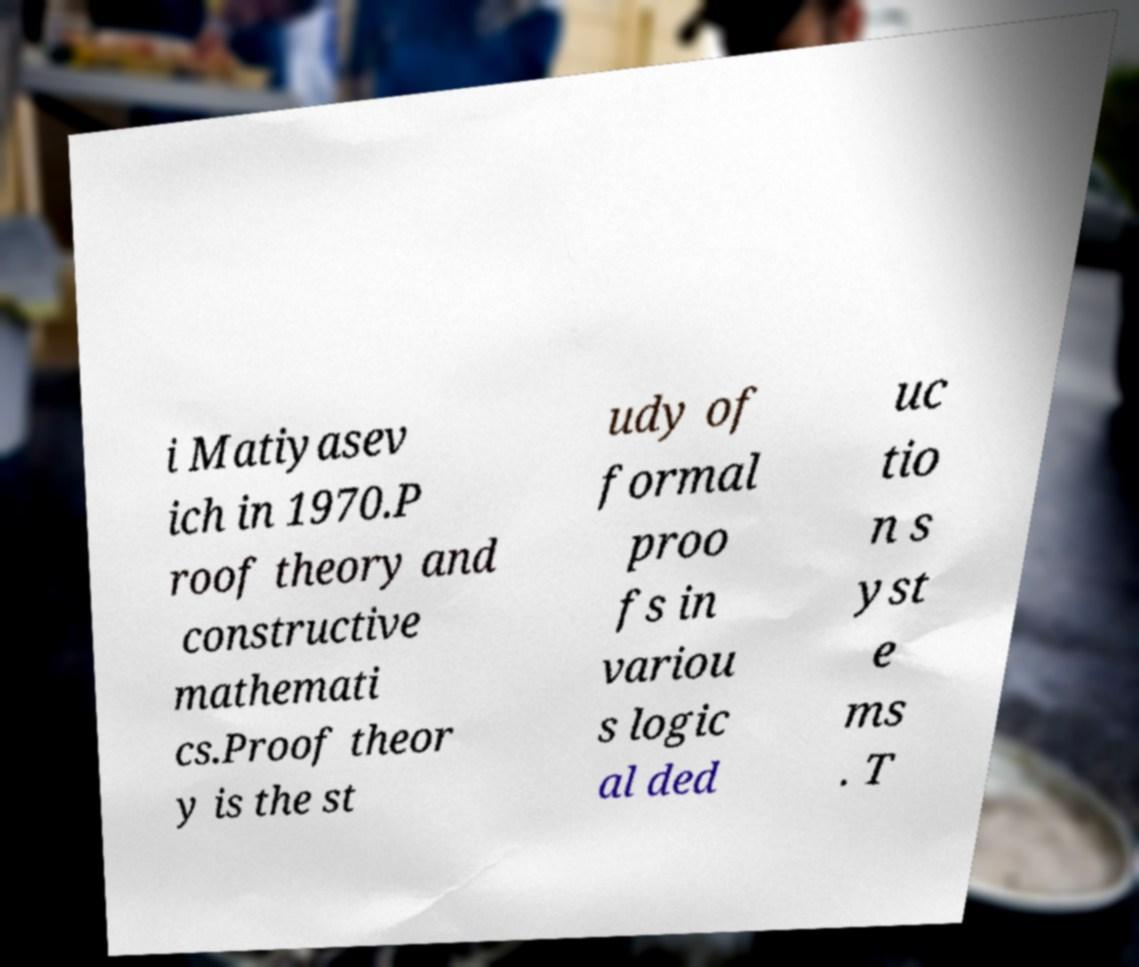There's text embedded in this image that I need extracted. Can you transcribe it verbatim? i Matiyasev ich in 1970.P roof theory and constructive mathemati cs.Proof theor y is the st udy of formal proo fs in variou s logic al ded uc tio n s yst e ms . T 